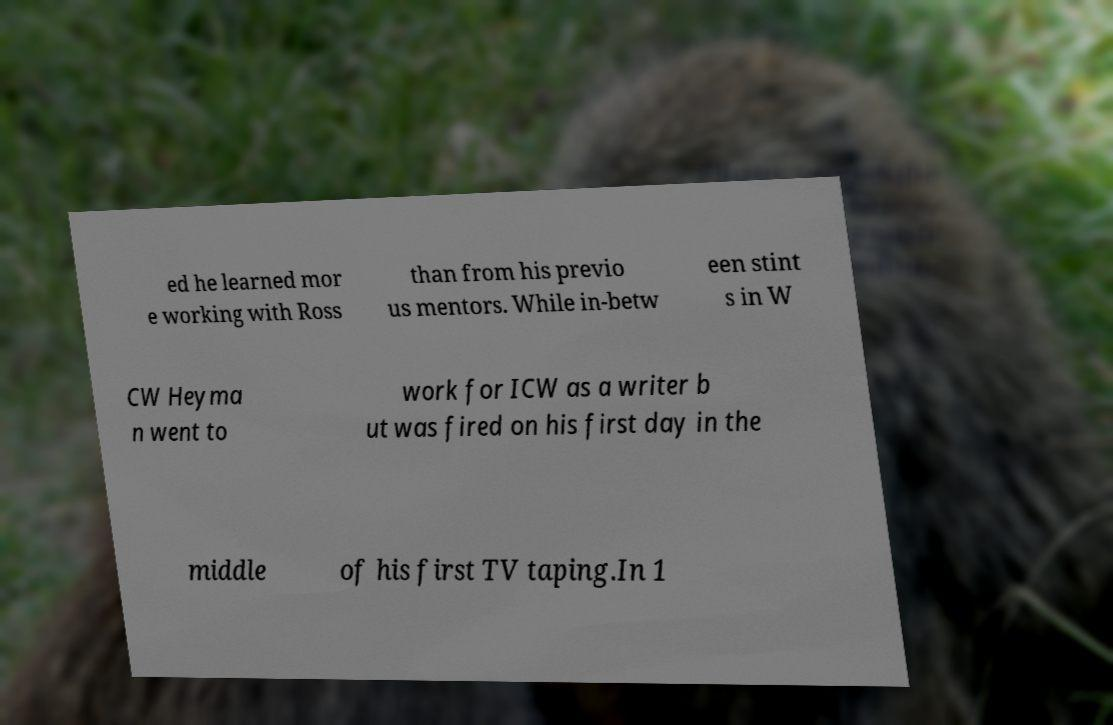What messages or text are displayed in this image? I need them in a readable, typed format. ed he learned mor e working with Ross than from his previo us mentors. While in-betw een stint s in W CW Heyma n went to work for ICW as a writer b ut was fired on his first day in the middle of his first TV taping.In 1 